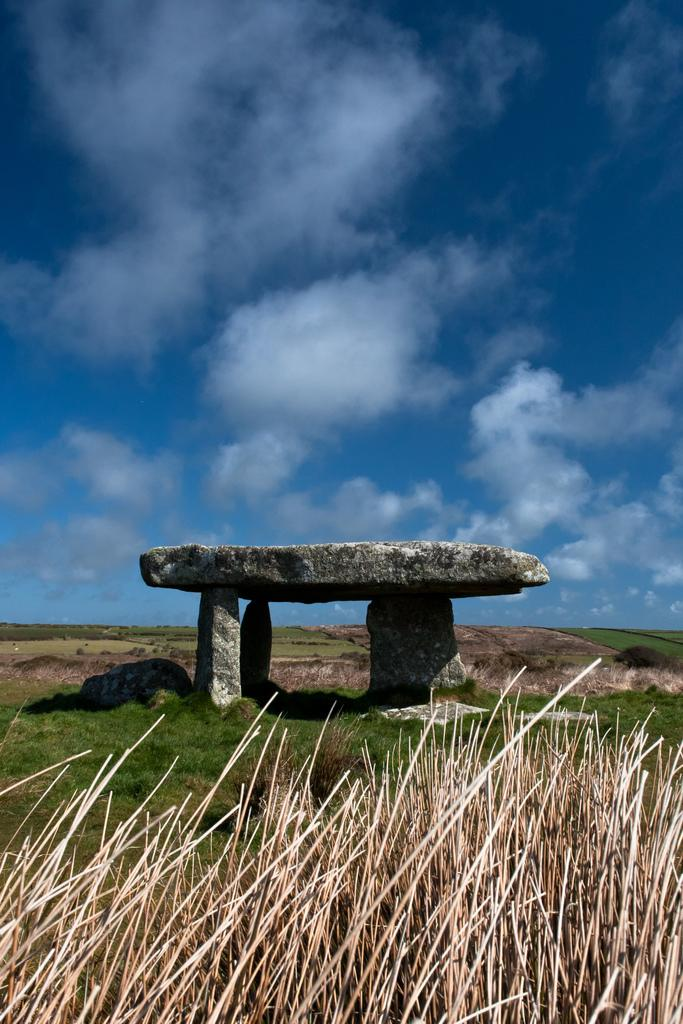What type of vegetation can be seen in the image? There is grass in the image. What else is present in the image besides grass? There are rocks in the image. What can be seen in the background of the image? The sky is visible in the background of the image. What is the condition of the sky in the image? Clouds are present in the sky. How many dimes are scattered among the rocks in the image? There are no dimes present in the image; it only features grass, rocks, and the sky. 